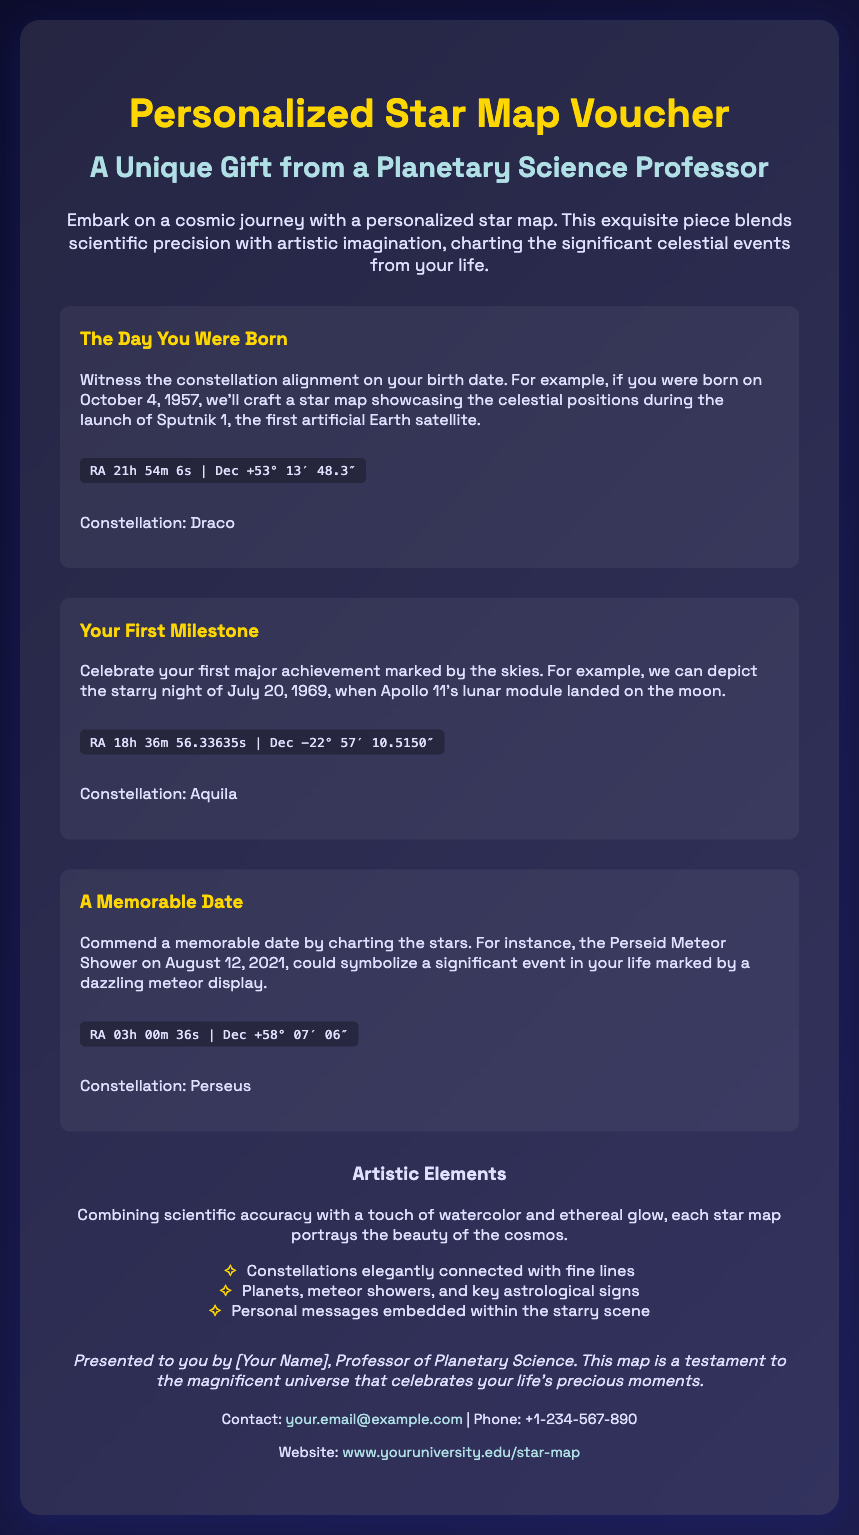What is the title of the voucher? The title of the voucher is prominently displayed at the top of the document.
Answer: Personalized Star Map Voucher Who is presenting the voucher? The footer specifies who the voucher is presented by, which is a title associated with the author.
Answer: Professor of Planetary Science What celestial event marks the day you were born in the example? The document provides an example of a significant celestial event related to birth dates.
Answer: Launch of Sputnik 1 What is the constellation mentioned for your first milestone? The document specifies which constellation is associated with the first milestone event.
Answer: Aquila What artistic feature is emphasized in the creation of the star maps? The artistic elements section describes a key aspect of how the star maps are designed.
Answer: Watercolor and ethereal glow What significant meteor event is referenced in the memorable date example? The document highlights an event that symbolizes a significant occasion by its celestial occurrence.
Answer: Perseid Meteor Shower What contact email is provided in the document? The contact section includes a means to reach the voucher's presenter.
Answer: your.email@example.com What type of celestial objects does the artistic elements section mention? This portion of the document lists different celestial objects included in the star maps.
Answer: Planets, meteor showers, and key astrological signs 